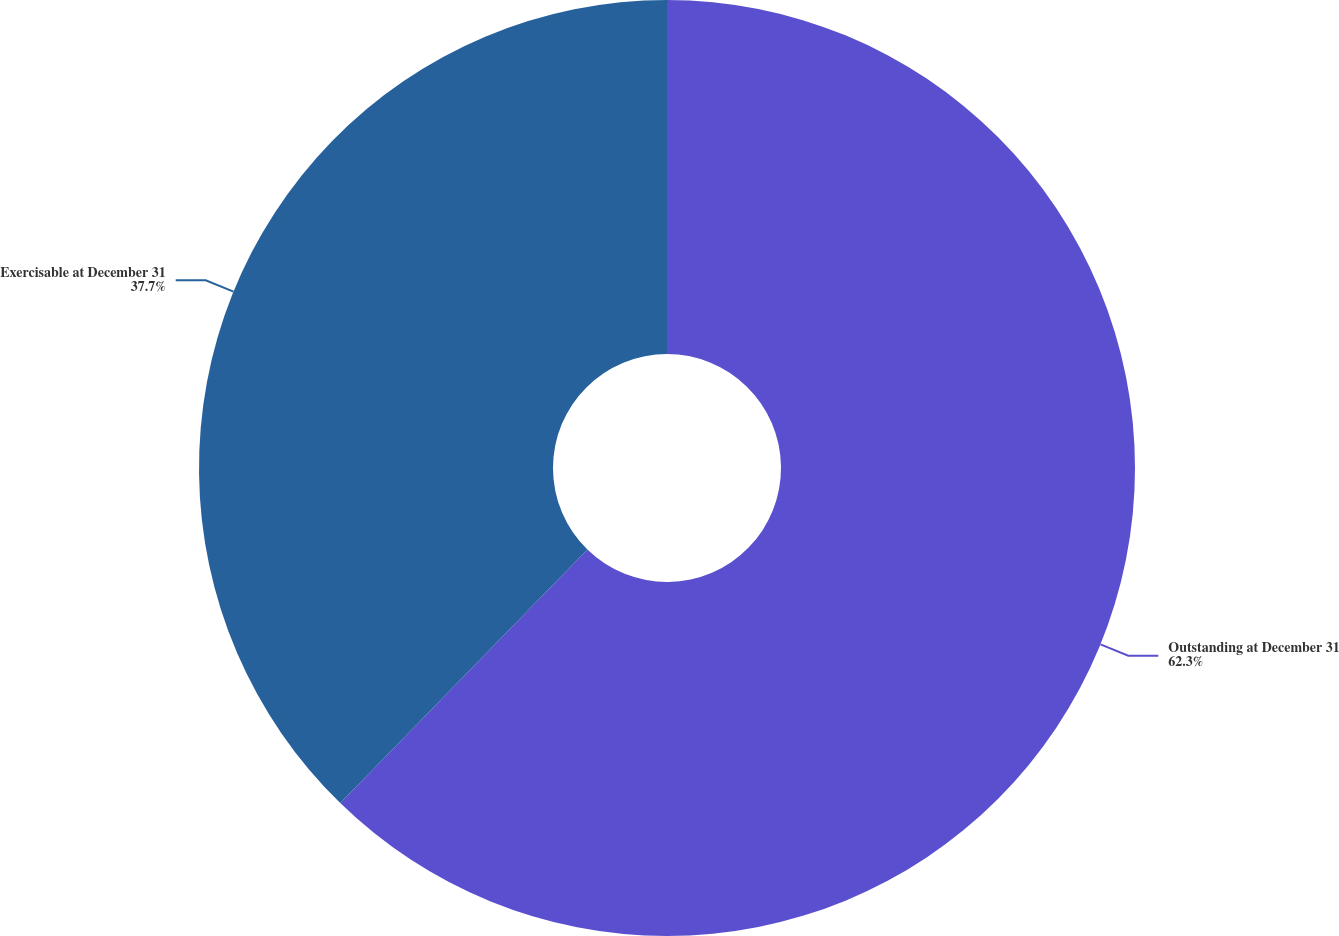Convert chart. <chart><loc_0><loc_0><loc_500><loc_500><pie_chart><fcel>Outstanding at December 31<fcel>Exercisable at December 31<nl><fcel>62.3%<fcel>37.7%<nl></chart> 